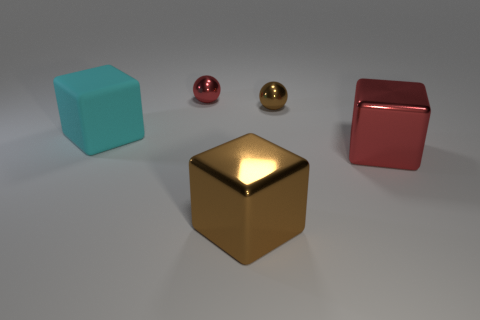Add 5 brown metal objects. How many objects exist? 10 Subtract all balls. How many objects are left? 3 Add 1 red blocks. How many red blocks exist? 2 Subtract 0 cyan balls. How many objects are left? 5 Subtract all large metallic things. Subtract all matte objects. How many objects are left? 2 Add 4 tiny red balls. How many tiny red balls are left? 5 